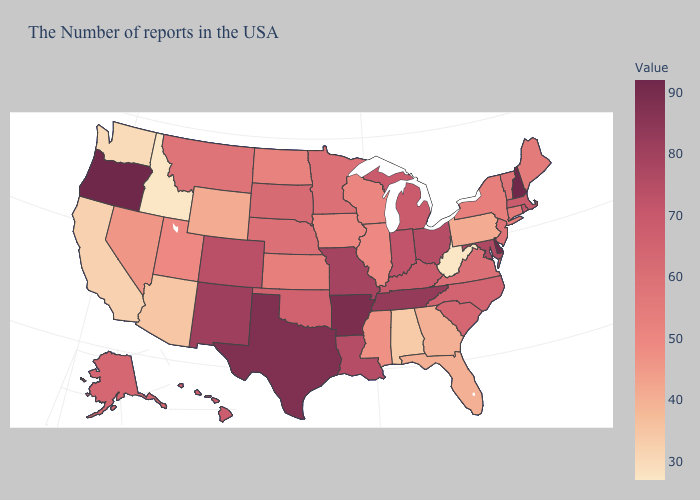Among the states that border Vermont , does New Hampshire have the highest value?
Answer briefly. Yes. Which states have the highest value in the USA?
Answer briefly. New Hampshire, Delaware, Oregon. Which states have the lowest value in the West?
Write a very short answer. Idaho. Does Massachusetts have the lowest value in the Northeast?
Be succinct. No. Does the map have missing data?
Keep it brief. No. Does Oregon have the highest value in the USA?
Be succinct. Yes. Among the states that border Georgia , does Alabama have the lowest value?
Write a very short answer. Yes. 